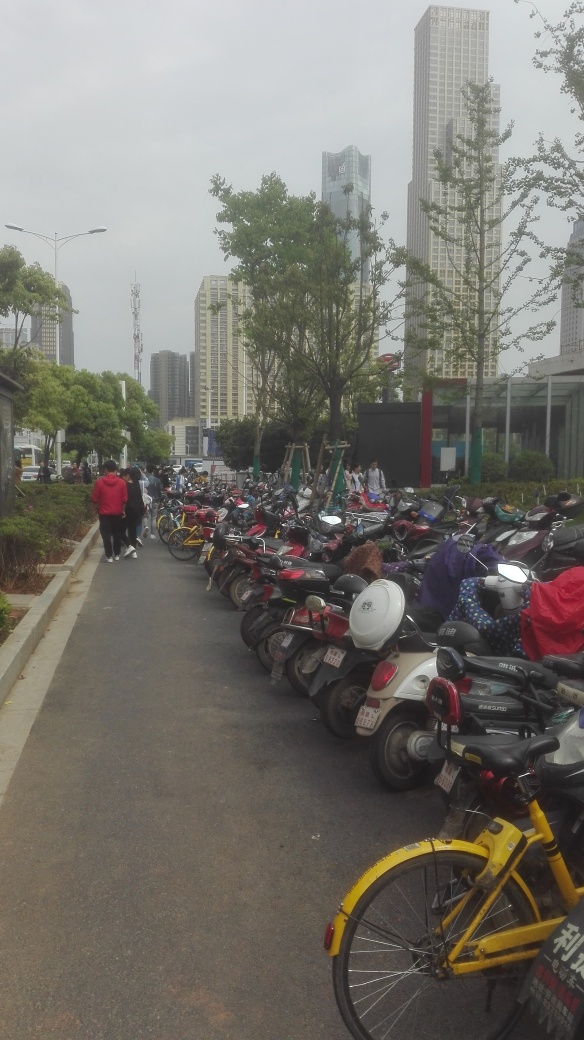Can you describe the weather in the image? The sky appears overcast, suggesting an overcast or cloudy day. The lighting is fairly uniform, and there are no shadows that would indicate strong sunlight. 